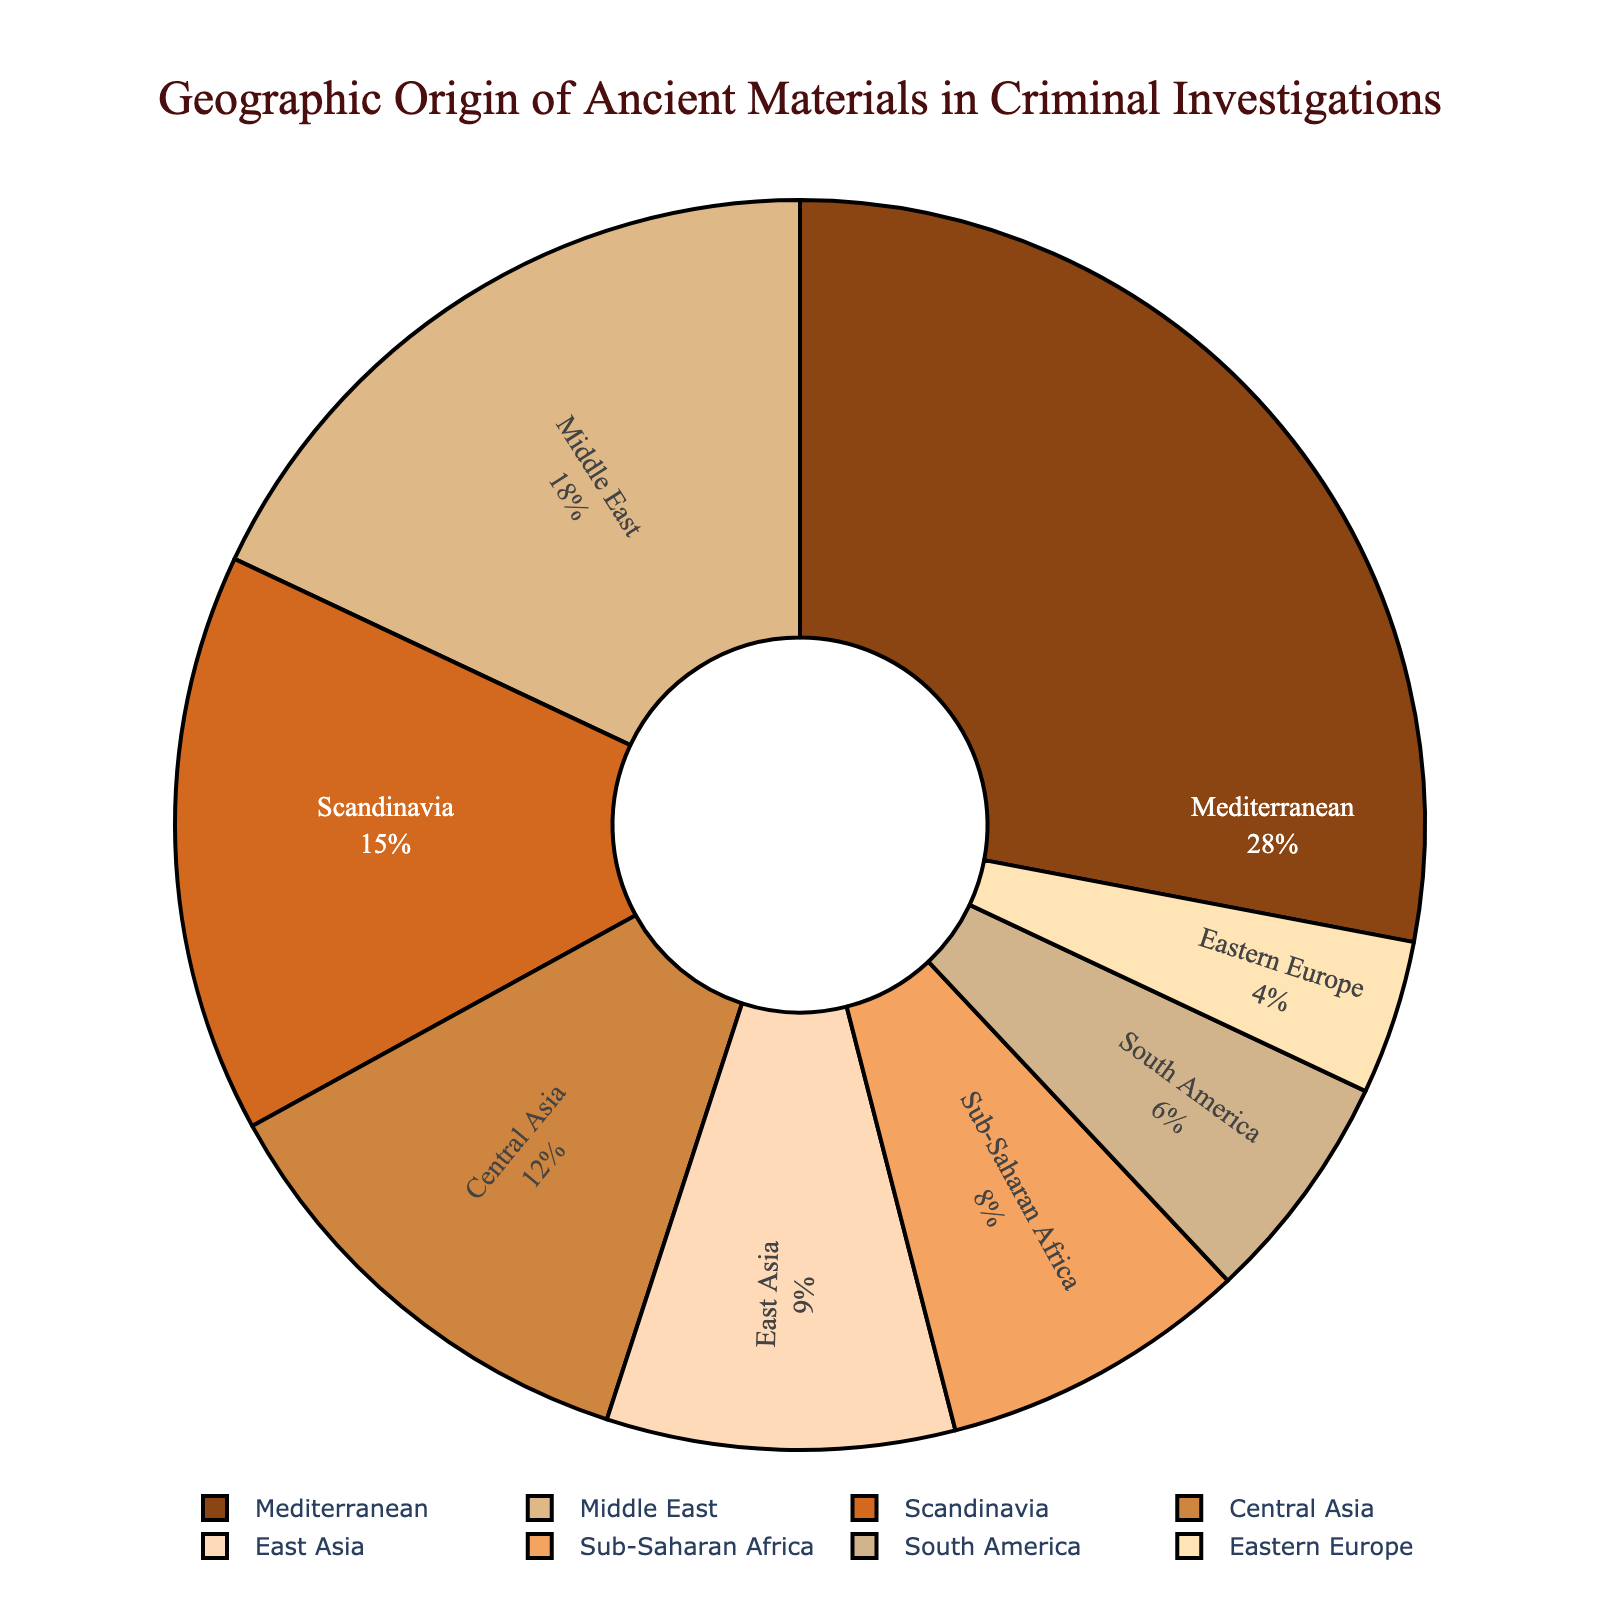Which region has the highest percentage of ancient materials? According to the pie chart, the Mediterranean region has the highest percentage.
Answer: Mediterranean Compare the percentages of ancient materials from the Middle East and Central Asia. Which one is greater? The pie chart shows that the Middle East has 18% and Central Asia has 12%, so the Middle East has a higher percentage.
Answer: Middle East What is the combined percentage of ancient materials from Scandinavia and East Asia? Adding the percentages from Scandinavia (15%) and East Asia (9%) gives a total of 15 + 9 = 24%.
Answer: 24% How much larger is the percentage of ancient materials from the Mediterranean compared to South America? The Mediterranean has 28% whereas South America has 6%. The difference is 28 - 6 = 22%.
Answer: 22% Which region has the smallest percentage, and what is it? Eastern Europe has the smallest percentage according to the pie chart, which is 4%.
Answer: Eastern Europe What percentage of ancient materials come from outside the Mediterranean, Central Asia, and Middle East combined? The total percentage for Mediterranean, Central Asia, and Middle East is 28% + 12% + 18% = 58%. The percentage of materials from other regions is 100% - 58% = 42%.
Answer: 42% Compare the combined percentage of ancient materials from the Middle East and East Asia to that of the Mediterranean region. Which is greater? Middle East and East Asia together have 18% + 9% = 27%. The Mediterranean alone has 28%, so the Mediterranean is greater.
Answer: Mediterranean Which regions have a percentage of ancient materials below 10%, and what are their percentages? According to the pie chart, Sub-Saharan Africa (8%), South America (6%), East Asia (9%), and Eastern Europe (4%) all have percentages below 10%.
Answer: Sub-Saharan Africa: 8%, South America: 6%, East Asia: 9%, Eastern Europe: 4% If the Mediterranean and Middle East percentages are combined, what fraction of the total would that represent? The combined percentage is 28% + 18% = 46%. As a fraction of the total (100%), this is 46/100 or simplified as 23/50.
Answer: 23/50 